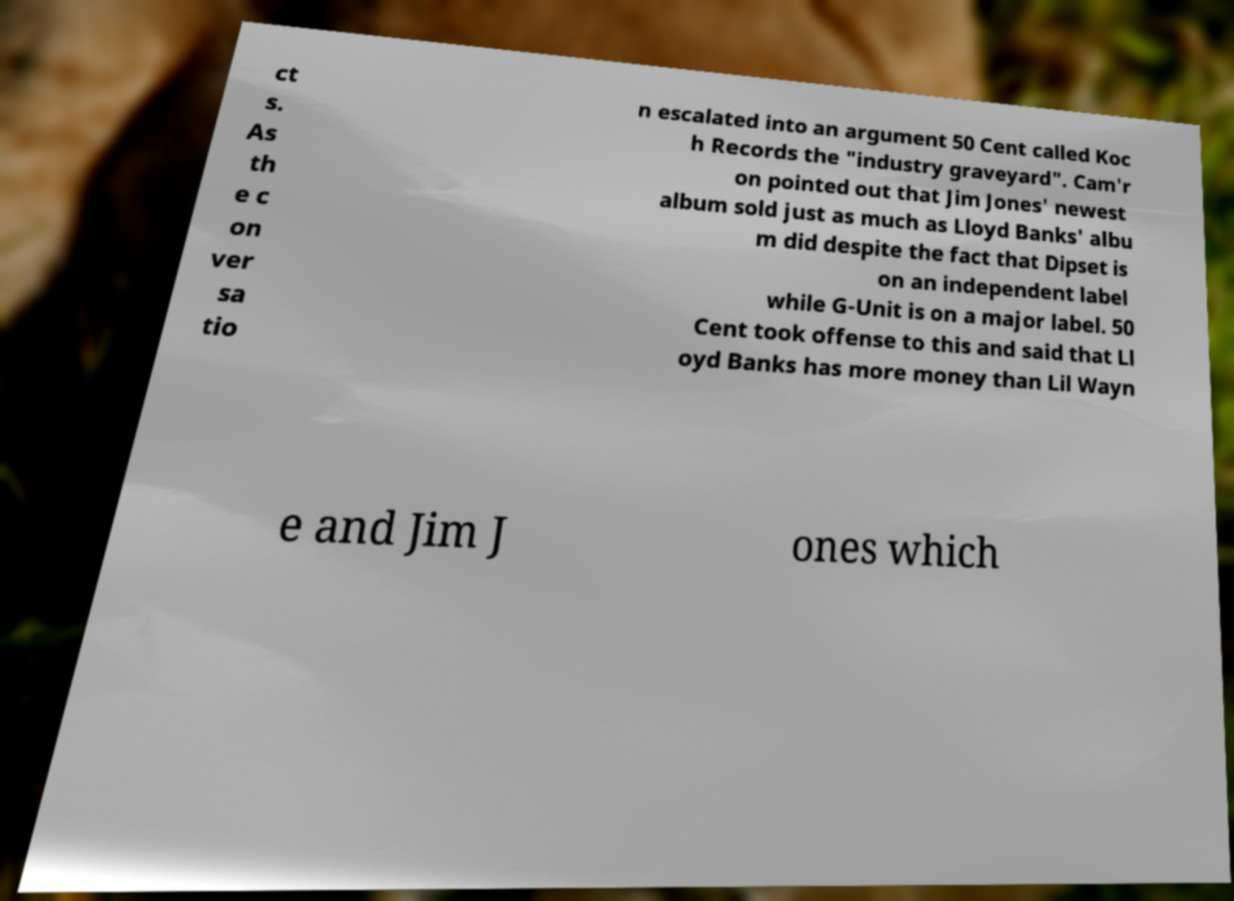Can you accurately transcribe the text from the provided image for me? ct s. As th e c on ver sa tio n escalated into an argument 50 Cent called Koc h Records the "industry graveyard". Cam'r on pointed out that Jim Jones' newest album sold just as much as Lloyd Banks' albu m did despite the fact that Dipset is on an independent label while G-Unit is on a major label. 50 Cent took offense to this and said that Ll oyd Banks has more money than Lil Wayn e and Jim J ones which 